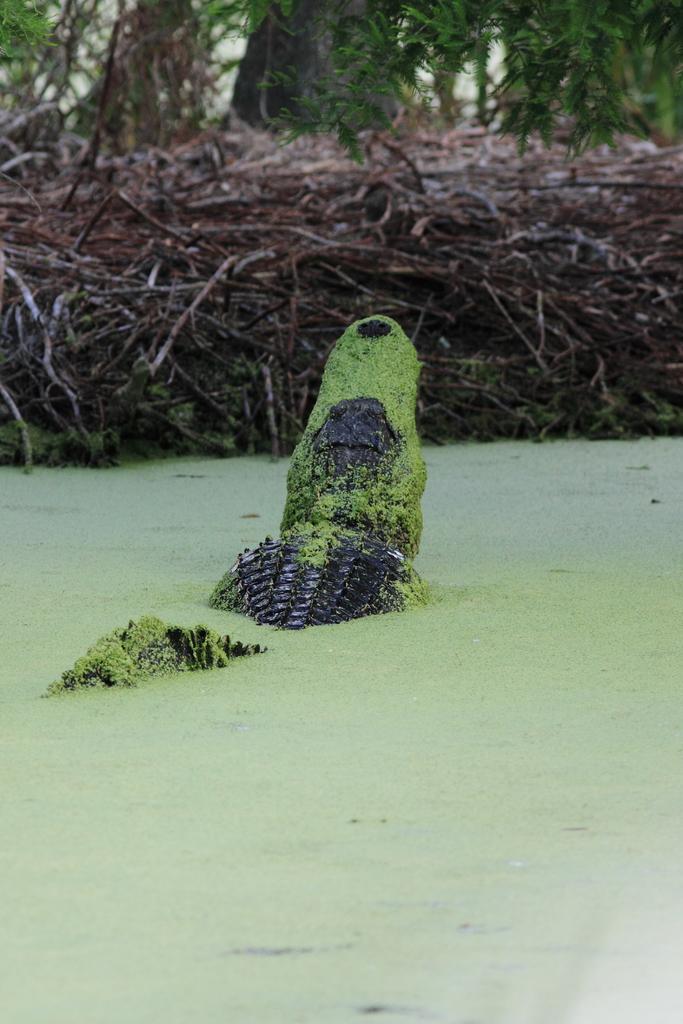Could you give a brief overview of what you see in this image? In this picture, I see a crocodile in the green color water and I see trees. 